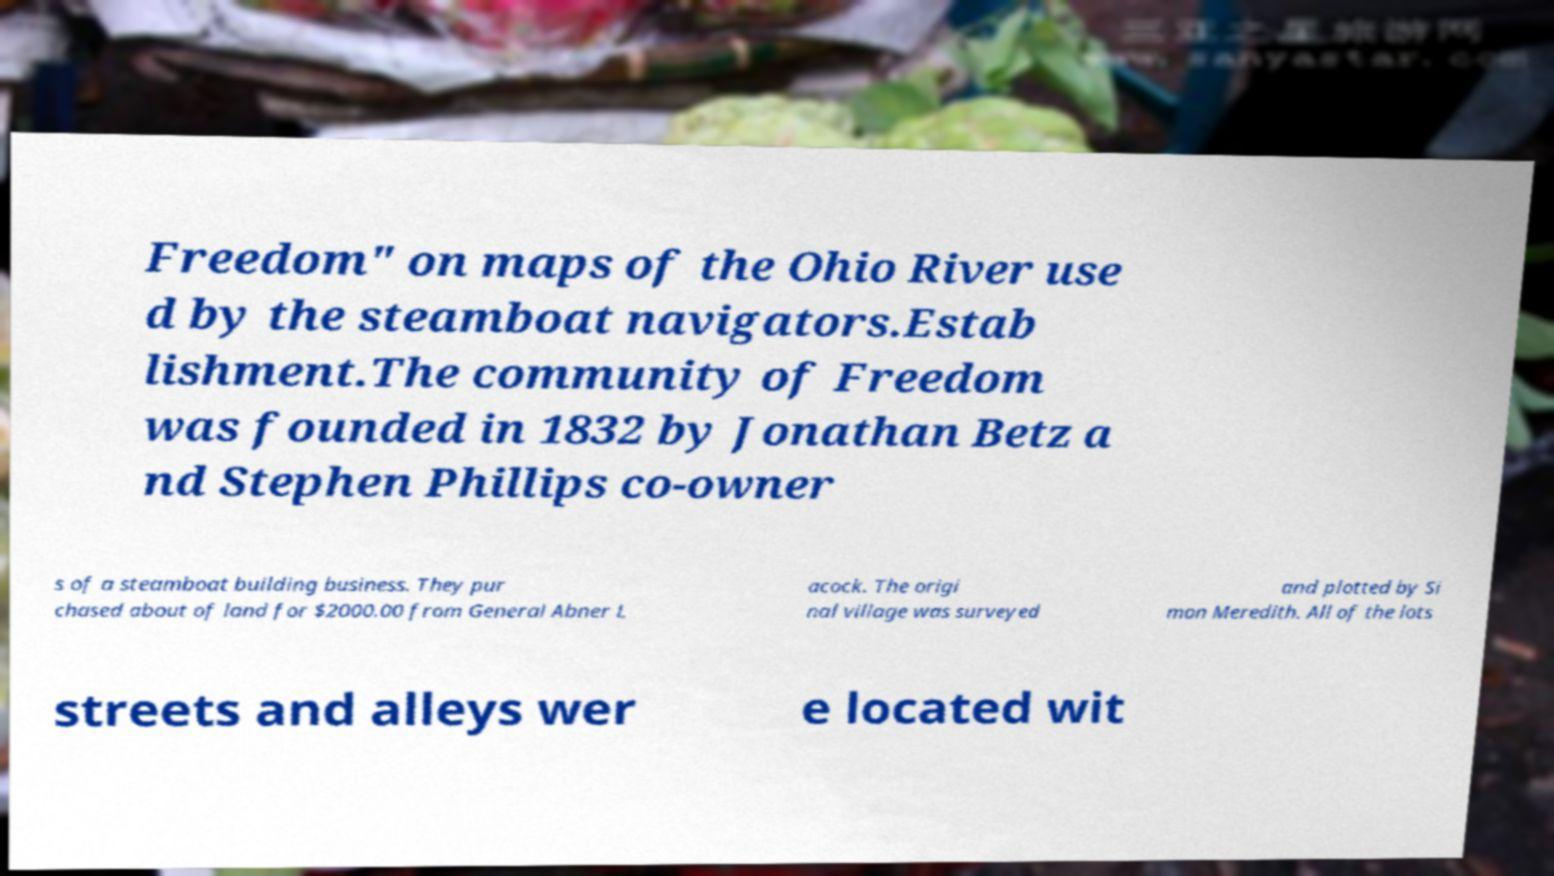Could you assist in decoding the text presented in this image and type it out clearly? Freedom" on maps of the Ohio River use d by the steamboat navigators.Estab lishment.The community of Freedom was founded in 1832 by Jonathan Betz a nd Stephen Phillips co-owner s of a steamboat building business. They pur chased about of land for $2000.00 from General Abner L acock. The origi nal village was surveyed and plotted by Si mon Meredith. All of the lots streets and alleys wer e located wit 